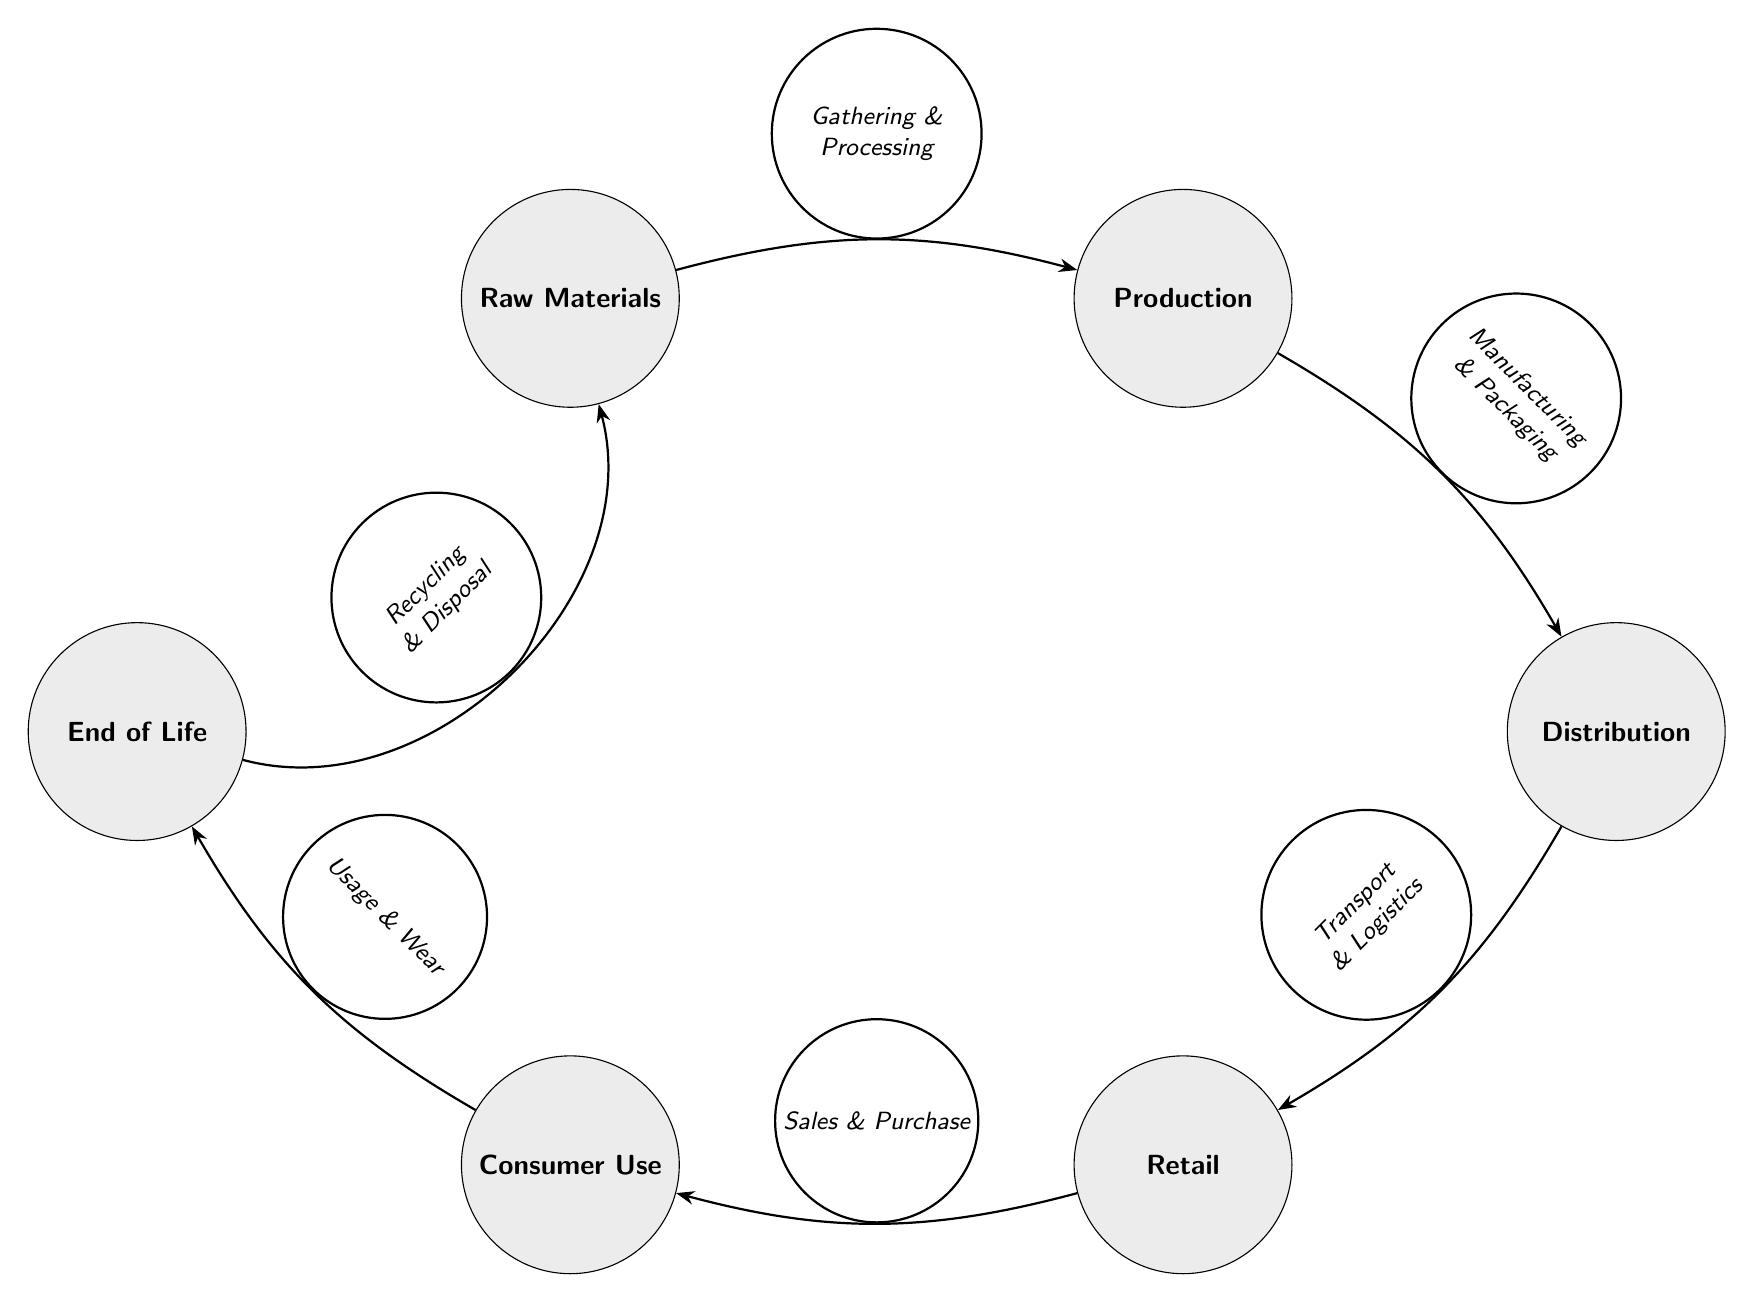What is the first stage in the lifecycle? The diagram shows "Raw Materials" as the starting point, indicating it is the first stage in the lifecycle.
Answer: Raw Materials How many stages are shown in the diagram? Counting the nodes present, there are six stages: Raw Materials, Production, Distribution, Retail, Consumer Use, and End of Life.
Answer: 6 What process occurs between Production and Distribution? The diagram indicates "Manufacturing & Packaging" as the process that connects the nodes, detailing the transition from Production to Distribution.
Answer: Manufacturing & Packaging Which two nodes are related by "Sales & Purchase"? The phrase "Sales & Purchase" connects "Retail" and "Consumer Use," indicating the relationship between these two stages.
Answer: Retail and Consumer Use What is the final stage before recycling? The diagram shows "End of Life" as the last stage before the recycling process, highlighting the lifecycle of materials when they are no longer in use.
Answer: End of Life What is the relationship between Consumer Use and End of Life? The connection is labeled "Usage & Wear," showing how the use of the product leads to its end of life, indicating a causative relationship.
Answer: Usage & Wear What goes after Distribution in the lifecycle? The diagram shows "Retail" as the next stage following Distribution, indicating a sequential flow in the lifecycle of car seat materials.
Answer: Retail What is the cycle back to Raw Materials labeled as? The transition from "End of Life" back to "Raw Materials" is labeled "Recycling & Disposal," establishing a return path for materials.
Answer: Recycling & Disposal Which stage involves "Transport & Logistics"? The connection from "Distribution" leads to "Retail" and is labeled "Transport & Logistics," indicating the necessary steps for distributing products to retailers.
Answer: Transport & Logistics 